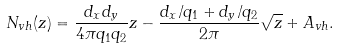Convert formula to latex. <formula><loc_0><loc_0><loc_500><loc_500>N _ { v h } ( z ) = \frac { d _ { x } d _ { y } } { 4 \pi q _ { 1 } q _ { 2 } } z - \frac { d _ { x } / q _ { 1 } + d _ { y } / q _ { 2 } } { 2 \pi } \sqrt { z } + A _ { v h } .</formula> 